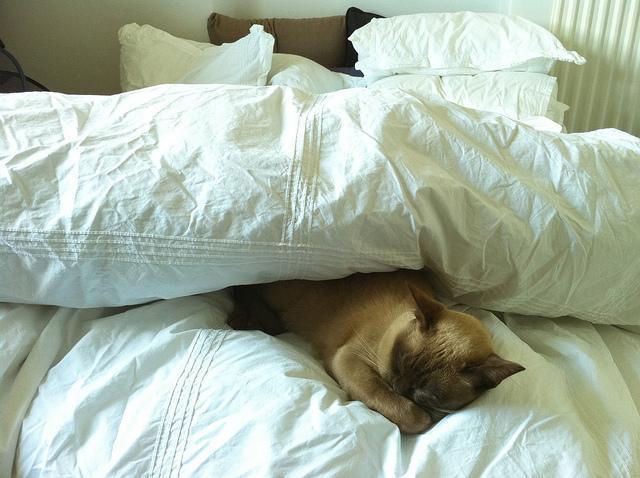How many grey bears are in the picture?
Give a very brief answer. 0. 